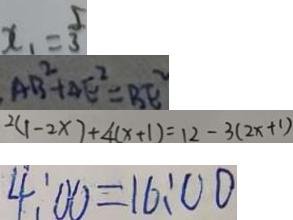Convert formula to latex. <formula><loc_0><loc_0><loc_500><loc_500>x _ { 1 } = \frac { 5 } { 3 } 
 A B ^ { 2 } + A E ^ { 2 } = B E ^ { 2 } 
 2 ( 1 - 2 x ) + 4 ( x + 1 ) = 1 2 - 3 ( 2 x + 1 ) 
 4 : 0 0 = 1 6 : 0 0</formula> 